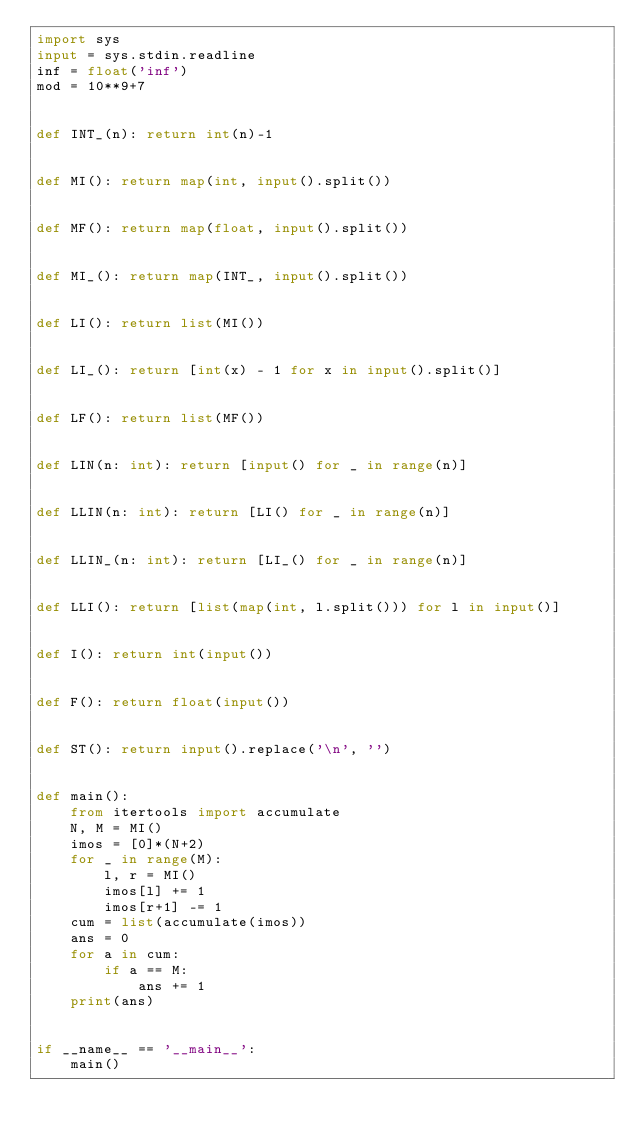Convert code to text. <code><loc_0><loc_0><loc_500><loc_500><_Python_>import sys
input = sys.stdin.readline
inf = float('inf')
mod = 10**9+7


def INT_(n): return int(n)-1


def MI(): return map(int, input().split())


def MF(): return map(float, input().split())


def MI_(): return map(INT_, input().split())


def LI(): return list(MI())


def LI_(): return [int(x) - 1 for x in input().split()]


def LF(): return list(MF())


def LIN(n: int): return [input() for _ in range(n)]


def LLIN(n: int): return [LI() for _ in range(n)]


def LLIN_(n: int): return [LI_() for _ in range(n)]


def LLI(): return [list(map(int, l.split())) for l in input()]


def I(): return int(input())


def F(): return float(input())


def ST(): return input().replace('\n', '')


def main():
    from itertools import accumulate
    N, M = MI()
    imos = [0]*(N+2)
    for _ in range(M):
        l, r = MI()
        imos[l] += 1
        imos[r+1] -= 1
    cum = list(accumulate(imos))
    ans = 0
    for a in cum:
        if a == M:
            ans += 1
    print(ans)


if __name__ == '__main__':
    main()
</code> 